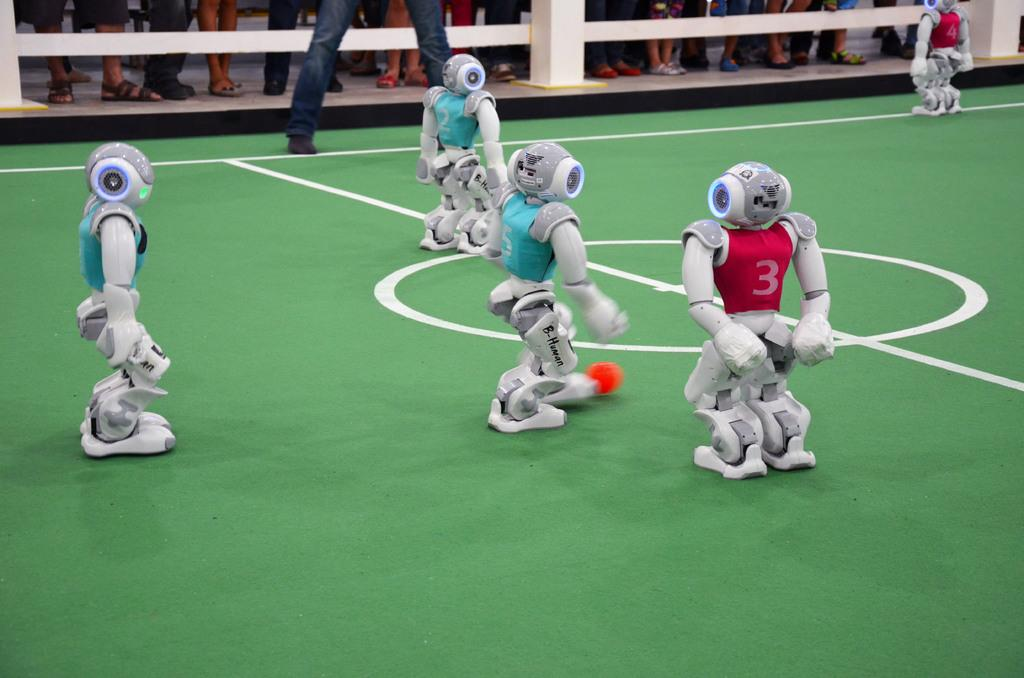<image>
Present a compact description of the photo's key features. Four robots on a field one with a red shirt that has a number 3 on it. 